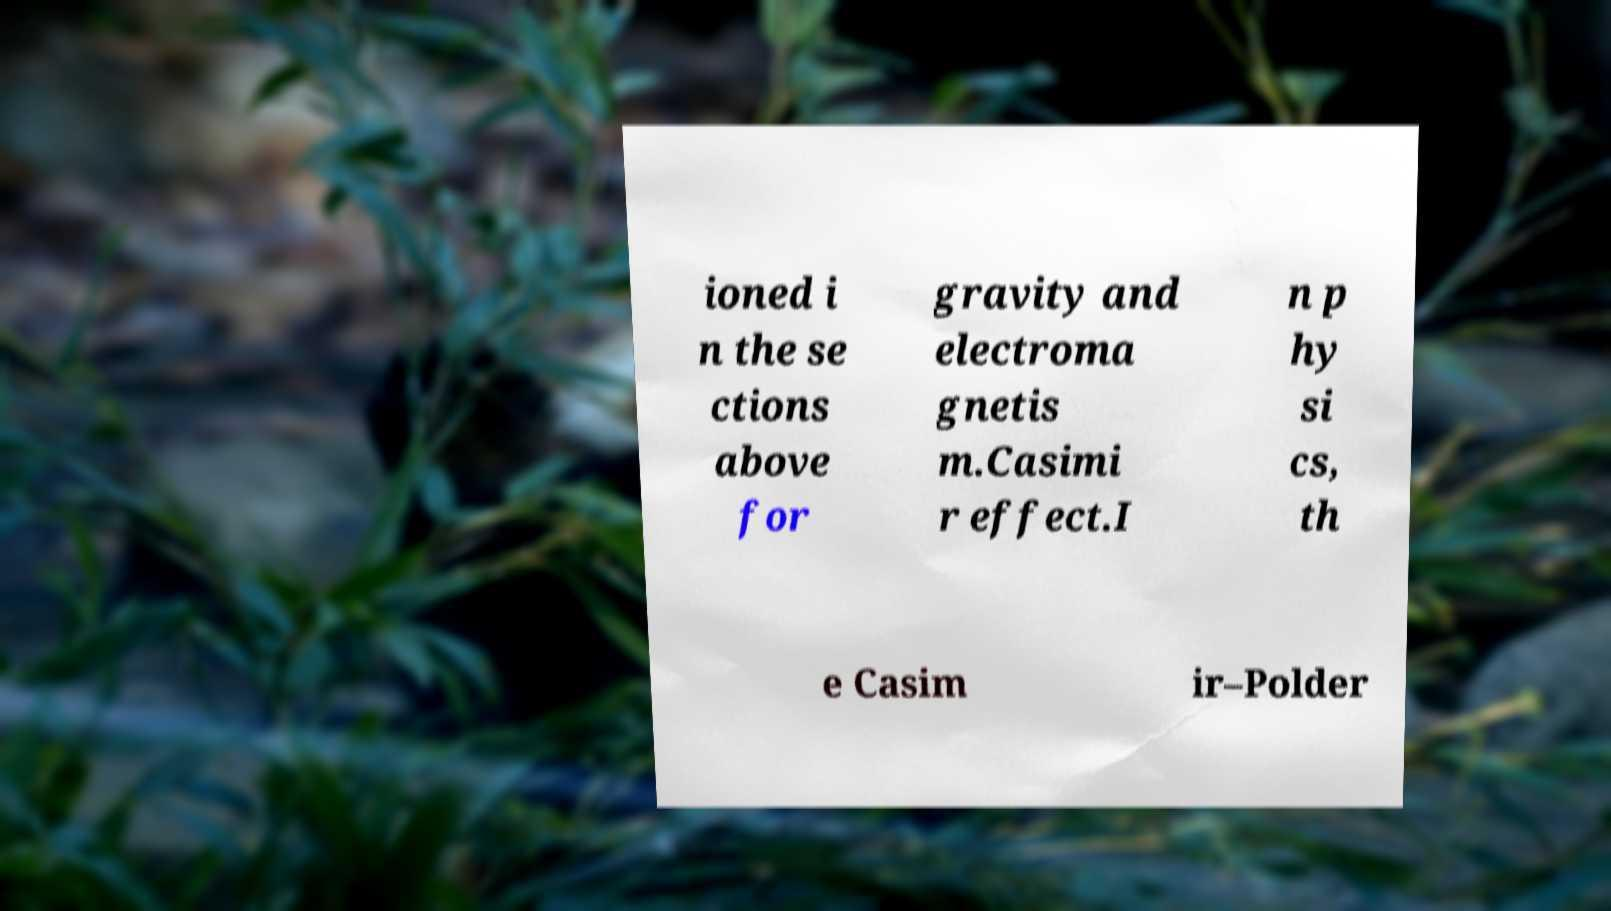Can you read and provide the text displayed in the image?This photo seems to have some interesting text. Can you extract and type it out for me? ioned i n the se ctions above for gravity and electroma gnetis m.Casimi r effect.I n p hy si cs, th e Casim ir–Polder 